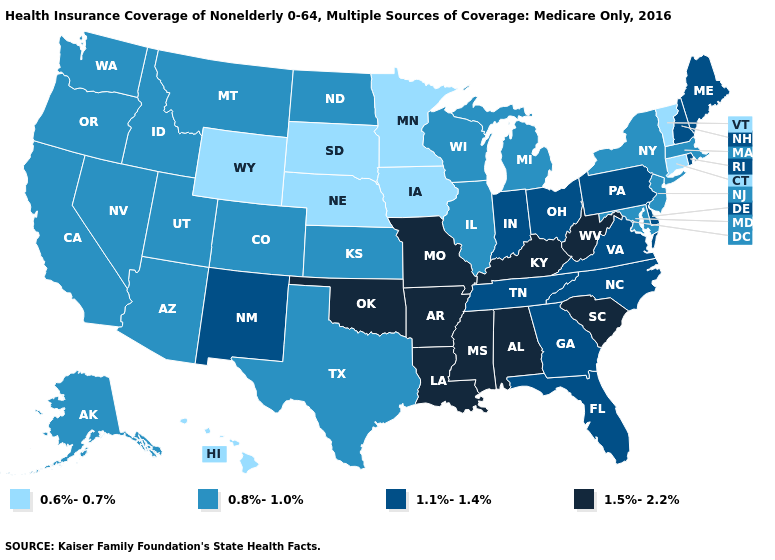What is the highest value in the USA?
Keep it brief. 1.5%-2.2%. Does Georgia have a lower value than Arkansas?
Be succinct. Yes. What is the value of New York?
Keep it brief. 0.8%-1.0%. What is the lowest value in states that border North Dakota?
Give a very brief answer. 0.6%-0.7%. What is the highest value in the USA?
Quick response, please. 1.5%-2.2%. What is the value of Louisiana?
Quick response, please. 1.5%-2.2%. Does Kentucky have the highest value in the USA?
Quick response, please. Yes. Name the states that have a value in the range 1.5%-2.2%?
Short answer required. Alabama, Arkansas, Kentucky, Louisiana, Mississippi, Missouri, Oklahoma, South Carolina, West Virginia. What is the lowest value in the West?
Keep it brief. 0.6%-0.7%. What is the value of South Dakota?
Write a very short answer. 0.6%-0.7%. What is the lowest value in the West?
Give a very brief answer. 0.6%-0.7%. Which states hav the highest value in the West?
Write a very short answer. New Mexico. What is the value of Nevada?
Give a very brief answer. 0.8%-1.0%. What is the value of Wisconsin?
Write a very short answer. 0.8%-1.0%. What is the value of Rhode Island?
Be succinct. 1.1%-1.4%. 